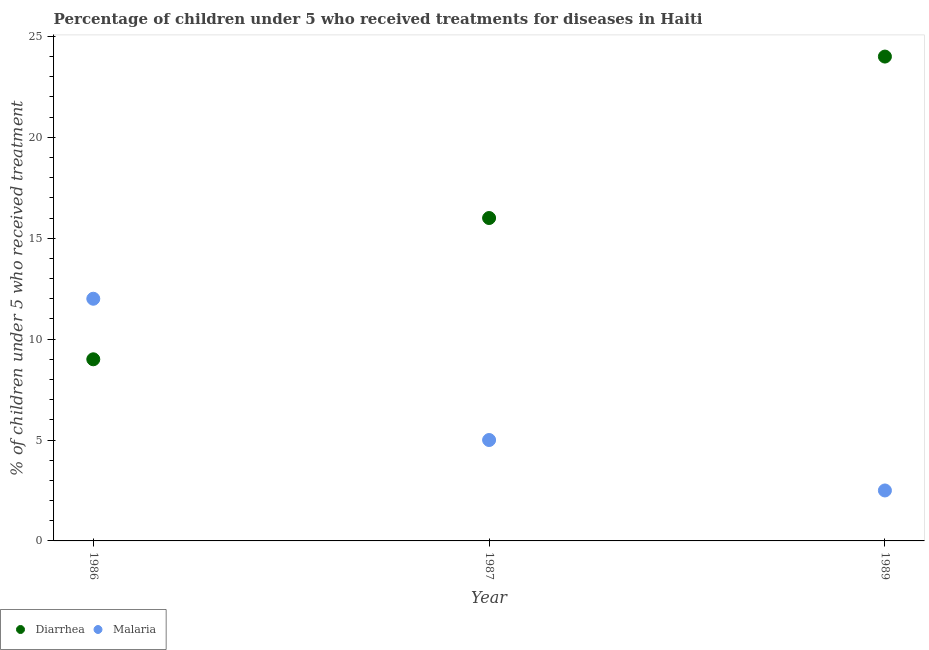How many different coloured dotlines are there?
Offer a terse response. 2. What is the percentage of children who received treatment for diarrhoea in 1989?
Offer a terse response. 24. Across all years, what is the maximum percentage of children who received treatment for diarrhoea?
Provide a succinct answer. 24. Across all years, what is the minimum percentage of children who received treatment for diarrhoea?
Offer a very short reply. 9. In which year was the percentage of children who received treatment for diarrhoea maximum?
Provide a succinct answer. 1989. In which year was the percentage of children who received treatment for malaria minimum?
Offer a terse response. 1989. What is the total percentage of children who received treatment for diarrhoea in the graph?
Offer a very short reply. 49. What is the difference between the percentage of children who received treatment for diarrhoea in 1987 and that in 1989?
Offer a terse response. -8. What is the ratio of the percentage of children who received treatment for diarrhoea in 1987 to that in 1989?
Offer a very short reply. 0.67. Is the difference between the percentage of children who received treatment for diarrhoea in 1987 and 1989 greater than the difference between the percentage of children who received treatment for malaria in 1987 and 1989?
Keep it short and to the point. No. What is the difference between the highest and the lowest percentage of children who received treatment for diarrhoea?
Ensure brevity in your answer.  15. In how many years, is the percentage of children who received treatment for malaria greater than the average percentage of children who received treatment for malaria taken over all years?
Provide a short and direct response. 1. Is the sum of the percentage of children who received treatment for malaria in 1987 and 1989 greater than the maximum percentage of children who received treatment for diarrhoea across all years?
Give a very brief answer. No. Does the percentage of children who received treatment for malaria monotonically increase over the years?
Your response must be concise. No. Is the percentage of children who received treatment for malaria strictly greater than the percentage of children who received treatment for diarrhoea over the years?
Your answer should be compact. No. What is the difference between two consecutive major ticks on the Y-axis?
Your answer should be compact. 5. Are the values on the major ticks of Y-axis written in scientific E-notation?
Keep it short and to the point. No. Does the graph contain any zero values?
Ensure brevity in your answer.  No. Does the graph contain grids?
Your answer should be compact. No. What is the title of the graph?
Offer a terse response. Percentage of children under 5 who received treatments for diseases in Haiti. What is the label or title of the X-axis?
Offer a very short reply. Year. What is the label or title of the Y-axis?
Provide a succinct answer. % of children under 5 who received treatment. What is the % of children under 5 who received treatment of Malaria in 1986?
Make the answer very short. 12. What is the % of children under 5 who received treatment of Malaria in 1987?
Your answer should be very brief. 5. What is the % of children under 5 who received treatment in Diarrhea in 1989?
Offer a terse response. 24. Across all years, what is the maximum % of children under 5 who received treatment of Diarrhea?
Your answer should be very brief. 24. Across all years, what is the minimum % of children under 5 who received treatment in Diarrhea?
Keep it short and to the point. 9. Across all years, what is the minimum % of children under 5 who received treatment in Malaria?
Your response must be concise. 2.5. What is the total % of children under 5 who received treatment of Diarrhea in the graph?
Your answer should be compact. 49. What is the difference between the % of children under 5 who received treatment in Diarrhea in 1986 and that in 1989?
Give a very brief answer. -15. What is the difference between the % of children under 5 who received treatment in Diarrhea in 1987 and that in 1989?
Give a very brief answer. -8. What is the difference between the % of children under 5 who received treatment in Malaria in 1987 and that in 1989?
Ensure brevity in your answer.  2.5. What is the difference between the % of children under 5 who received treatment in Diarrhea in 1987 and the % of children under 5 who received treatment in Malaria in 1989?
Offer a very short reply. 13.5. What is the average % of children under 5 who received treatment of Diarrhea per year?
Keep it short and to the point. 16.33. What is the average % of children under 5 who received treatment in Malaria per year?
Offer a very short reply. 6.5. In the year 1987, what is the difference between the % of children under 5 who received treatment in Diarrhea and % of children under 5 who received treatment in Malaria?
Give a very brief answer. 11. What is the ratio of the % of children under 5 who received treatment in Diarrhea in 1986 to that in 1987?
Ensure brevity in your answer.  0.56. What is the ratio of the % of children under 5 who received treatment in Malaria in 1986 to that in 1987?
Provide a succinct answer. 2.4. What is the ratio of the % of children under 5 who received treatment of Diarrhea in 1986 to that in 1989?
Keep it short and to the point. 0.38. What is the ratio of the % of children under 5 who received treatment of Malaria in 1986 to that in 1989?
Keep it short and to the point. 4.8. What is the ratio of the % of children under 5 who received treatment in Diarrhea in 1987 to that in 1989?
Keep it short and to the point. 0.67. What is the ratio of the % of children under 5 who received treatment in Malaria in 1987 to that in 1989?
Your answer should be compact. 2. What is the difference between the highest and the second highest % of children under 5 who received treatment of Diarrhea?
Your response must be concise. 8. 